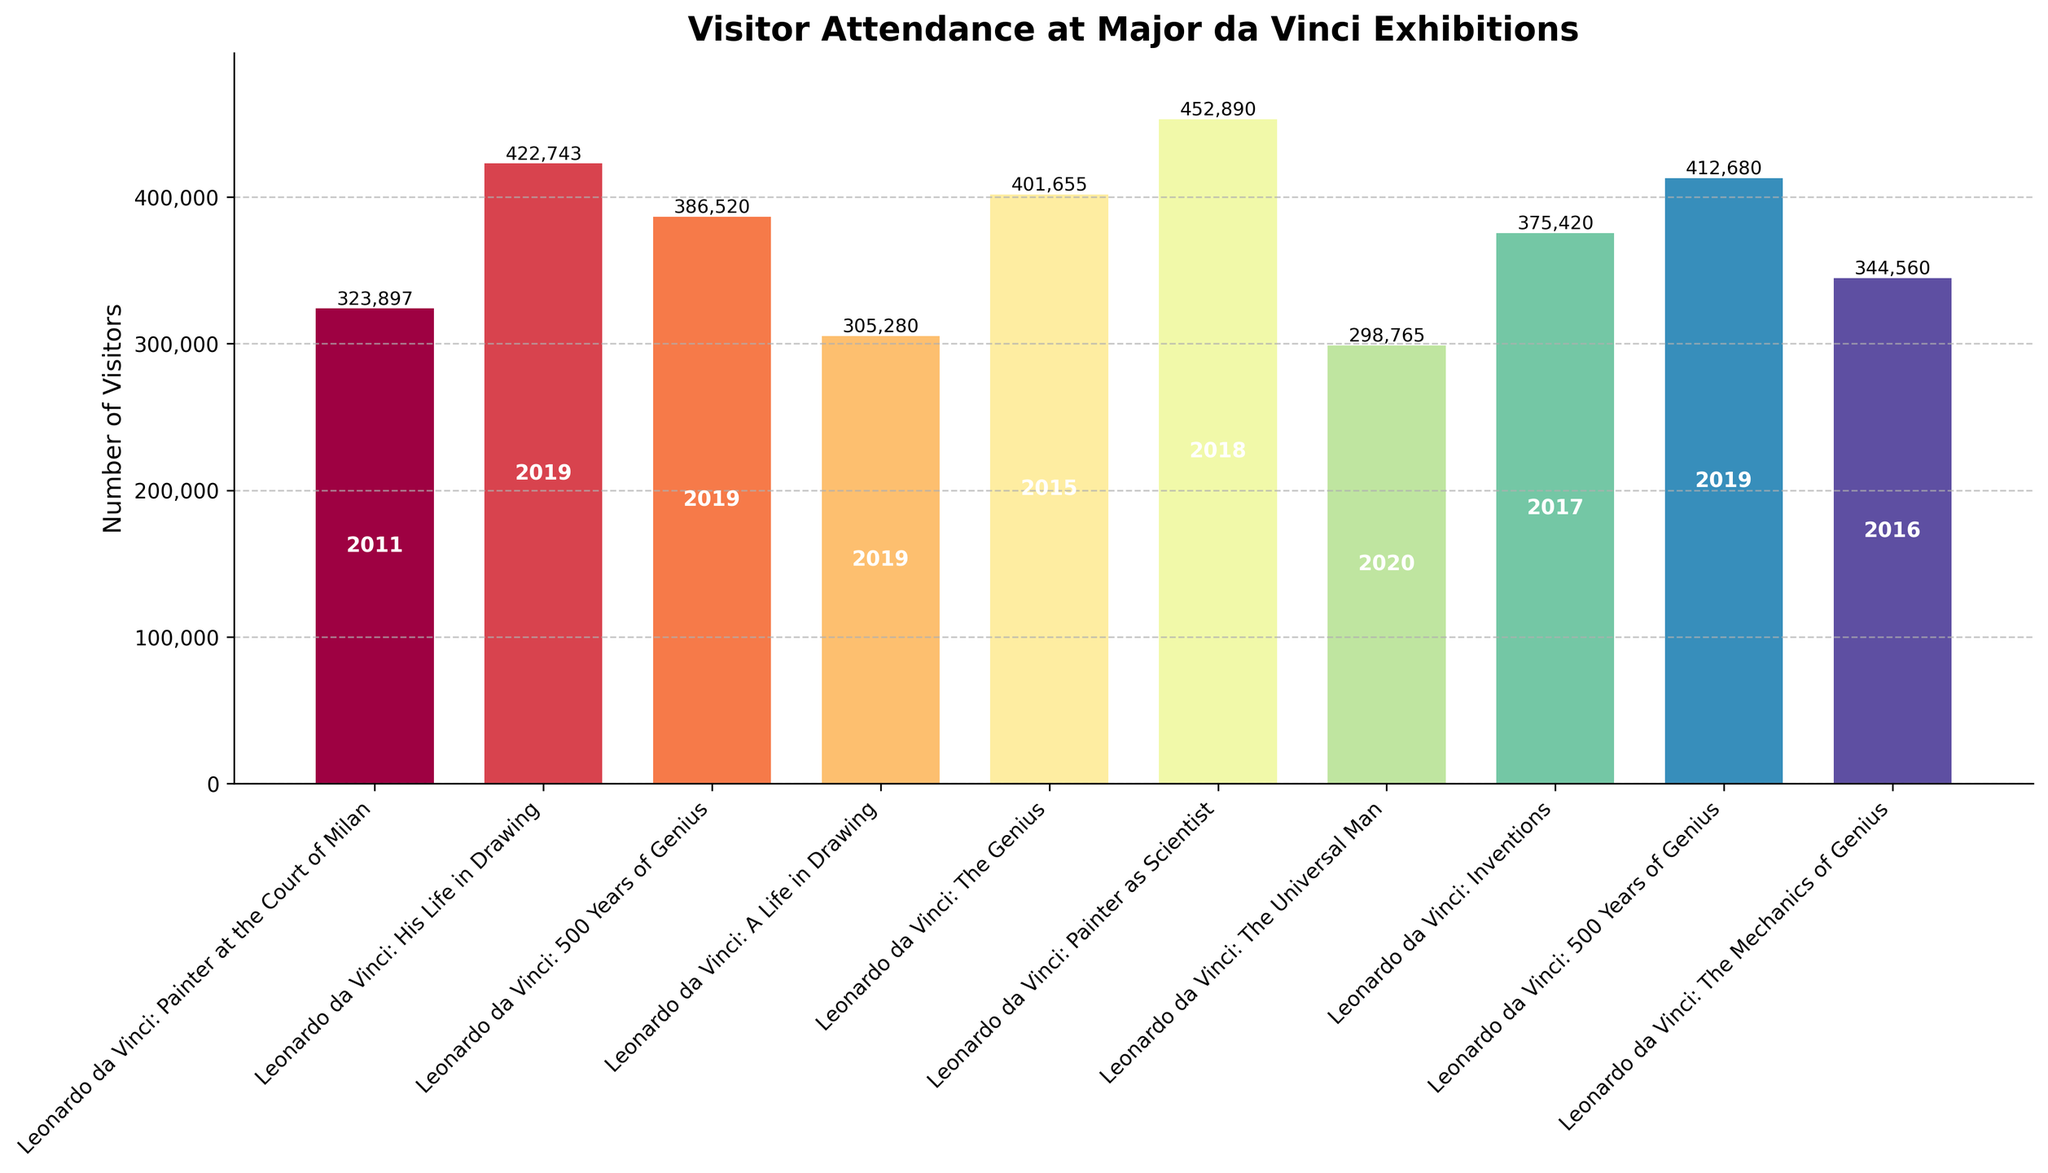Which exhibition had the highest number of visitors? Look at the heights of the bars and find the tallest one. The "Leonardo da Vinci: Painter as Scientist (Uffizi Gallery Florence)" bar is the tallest.
Answer: Leonardo da Vinci: Painter as Scientist (Uffizi Gallery Florence) Which year had the highest number of visitors across all exhibitions? Check the bars and identify the ones with the highest visitation numbers. The bar for 2019 “Leonardo da Vinci: His Life in Drawing (Royal Collection Trust UK)” shows the highest number.
Answer: 2019 Which exhibition had the lowest number of visitors? Look for the shortest bar in the chart. The bar for "Leonardo da Vinci: The Universal Man (Louvre Abu Dhabi)" is the shortest.
Answer: Leonardo da Vinci: The Universal Man (Louvre Abu Dhabi) What is the total number of visitors for the exhibitions held in 2019? Locate the bars labeled with the year 2019 and sum their heights (visitors). The exhibitions in 2019 are “Leonardo da Vinci: His Life in Drawing (422,743)”, “Leonardo da Vinci: 500 Years of Genius (Denver Museum of Nature & Science)” (386,520), “Leonardo da Vinci: A Life in Drawing (305,280)” and “Leonardo da Vinci: 500 Years of Genius (California Science Center)” (412,680). Adding these gives a total of 1,527,223.
Answer: 1,527,223 Which two exhibitions have the largest difference in the number of visitors? Compare all pairs of bars to find which pair has the largest difference in height. "Leonardo da Vinci: Painter as Scientist (Uffizi Gallery Florence)" and "Leonardo da Vinci: The Universal Man (Louvre Abu Dhabi)" have the largest difference (452,890 - 298,765 = 154,125).
Answer: Leonardo da Vinci: Painter as Scientist (Uffizi Gallery Florence) and Leonardo da Vinci: The Universal Man (Louvre Abu Dhabi) How many exhibitions had more than 400,000 visitors? Count the bars that exceed the 400,000 mark. These exhibitions are: "Leonardo da Vinci: Painter as Scientist", "Leonardo da Vinci: His Life in Drawing", "Leonardo da Vinci: The Genius", and "Leonardo da Vinci: 500 Years of Genius (California Science Center)".
Answer: 4 What is the average number of visitors for all exhibitions held between 2015 and 2020? Identify the bars for the years 2015-2020, sum up their heights (visitors), and then divide by the number of bars. The exhibitions are:
2015: The Genius (401,655)
2016: The Mechanics of Genius (344,560)
2017: Inventions (375,420)
2018: Painter as Scientist (452,890)
2019: 4 exhibitions (422,743 + 386,520 + 305,280 + 412,680)
2020: The Universal Man (298,765)
Sum = 3,400,513 and total number of exhibitions = 9. Average = 3,400,513 / 9 ≈ 377,835.
Answer: 377,835 Which exhibition held in the UK had the highest number of visitors? Focus on the exhibitions located in the UK and find the tallest bar among them. "Leonardo da Vinci: His Life in Drawing (Royal Collection Trust UK)" has the highest visitors in the UK.
Answer: Leonardo da Vinci: His Life in Drawing (Royal Collection Trust UK) Which exhibition had fewer visitors: "The Universal Man (Louvre Abu Dhabi)" or "Painter at the Court of Milan (National Gallery London)"? Compare the heights of the two bars. "The Universal Man (Louvre Abu Dhabi)" had fewer visitors than "Painter at the Court of Milan (National Gallery London)" (298,765 vs 323,897).
Answer: The Universal Man (Louvre Abu Dhabi) How does the "Leonardo da Vinci: Painter as Scientist (Uffizi Gallery Florence)" attendance compare to the "Leonardo da Vinci: The Genius (National Museum of Science and Technology Milan)"? Compare the heights of the two bars. "Leonardo da Vinci: Painter as Scientist" (452,890) had more visitors than "Leonardo da Vinci: The Genius" (401,655).
Answer: Painter as Scientist (Uffizi Gallery Florence) had more visitors 